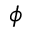<formula> <loc_0><loc_0><loc_500><loc_500>\phi</formula> 